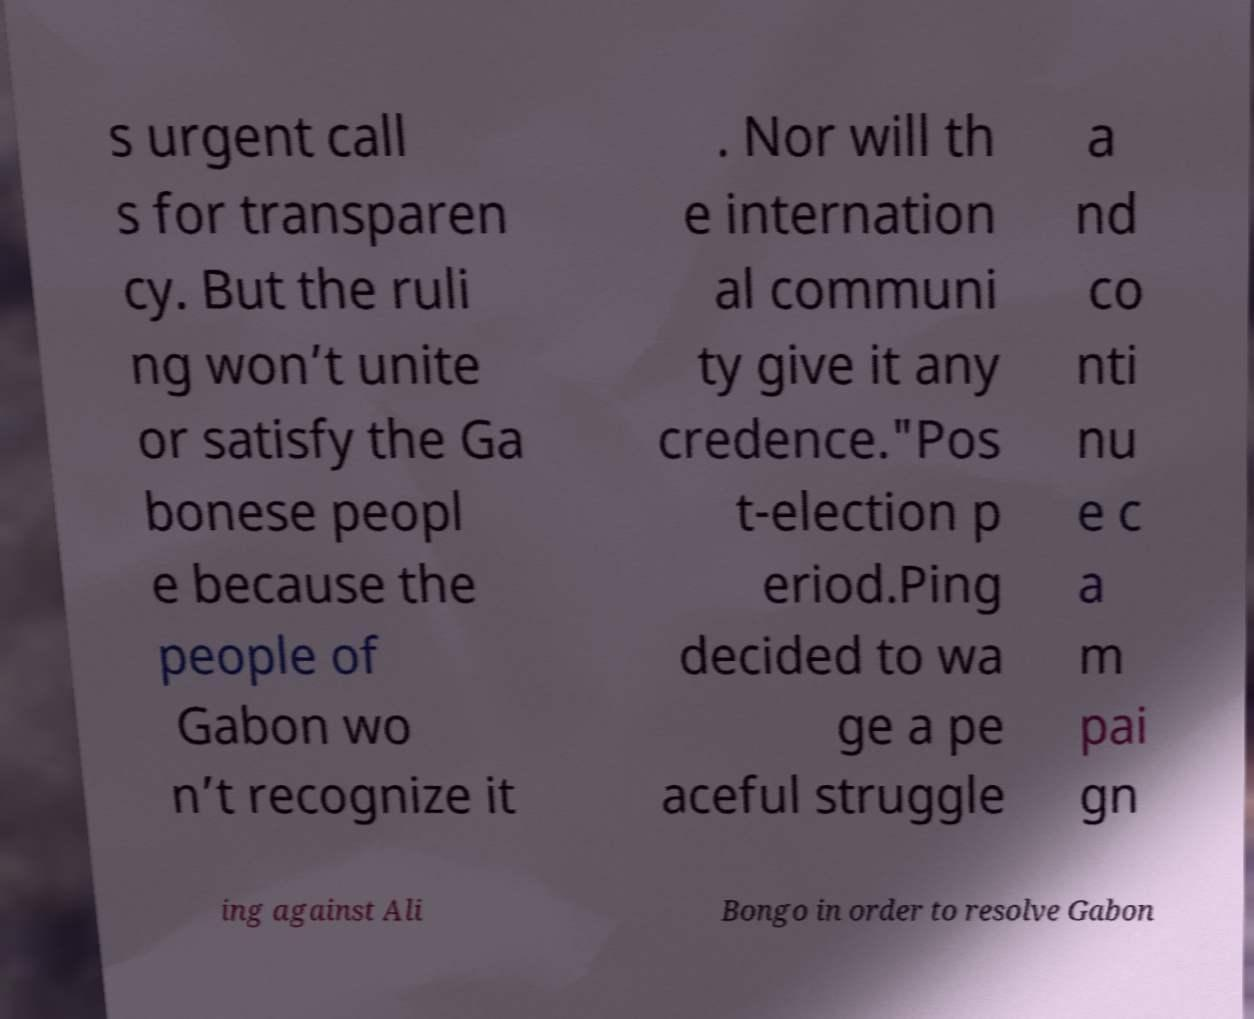Could you extract and type out the text from this image? s urgent call s for transparen cy. But the ruli ng won’t unite or satisfy the Ga bonese peopl e because the people of Gabon wo n’t recognize it . Nor will th e internation al communi ty give it any credence."Pos t-election p eriod.Ping decided to wa ge a pe aceful struggle a nd co nti nu e c a m pai gn ing against Ali Bongo in order to resolve Gabon 